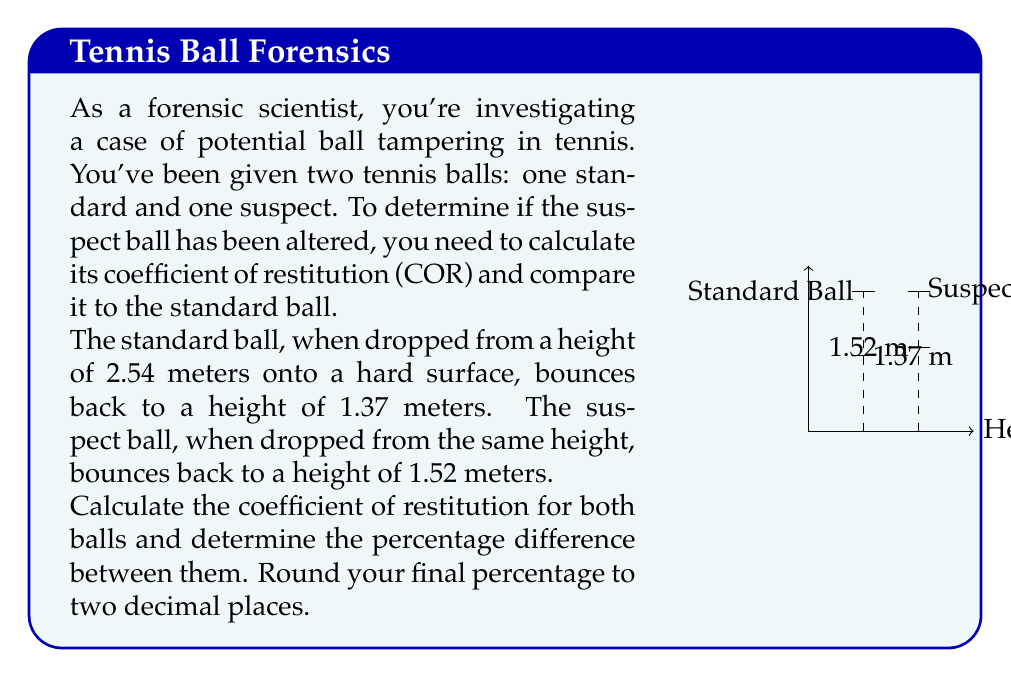What is the answer to this math problem? Let's approach this step-by-step:

1) The coefficient of restitution (COR) is calculated using the formula:

   $$COR = \sqrt{\frac{h_f}{h_i}}$$

   Where $h_f$ is the final (bounce) height and $h_i$ is the initial drop height.

2) For the standard ball:
   $$COR_{standard} = \sqrt{\frac{1.37}{2.54}} = \sqrt{0.5394} = 0.7344$$

3) For the suspect ball:
   $$COR_{suspect} = \sqrt{\frac{1.52}{2.54}} = \sqrt{0.5984} = 0.7736$$

4) To calculate the percentage difference, we use the formula:

   $$\text{Percentage Difference} = \frac{|COR_{suspect} - COR_{standard}|}{COR_{standard}} \times 100\%$$

5) Plugging in our values:

   $$\text{Percentage Difference} = \frac{|0.7736 - 0.7344|}{0.7344} \times 100\% = 0.0533 \times 100\% = 5.33\%$$

6) Rounding to two decimal places: 5.33%

This significant difference in COR suggests that the suspect ball may indeed have been tampered with, as it has a higher bounce than the standard ball.
Answer: 5.33% 